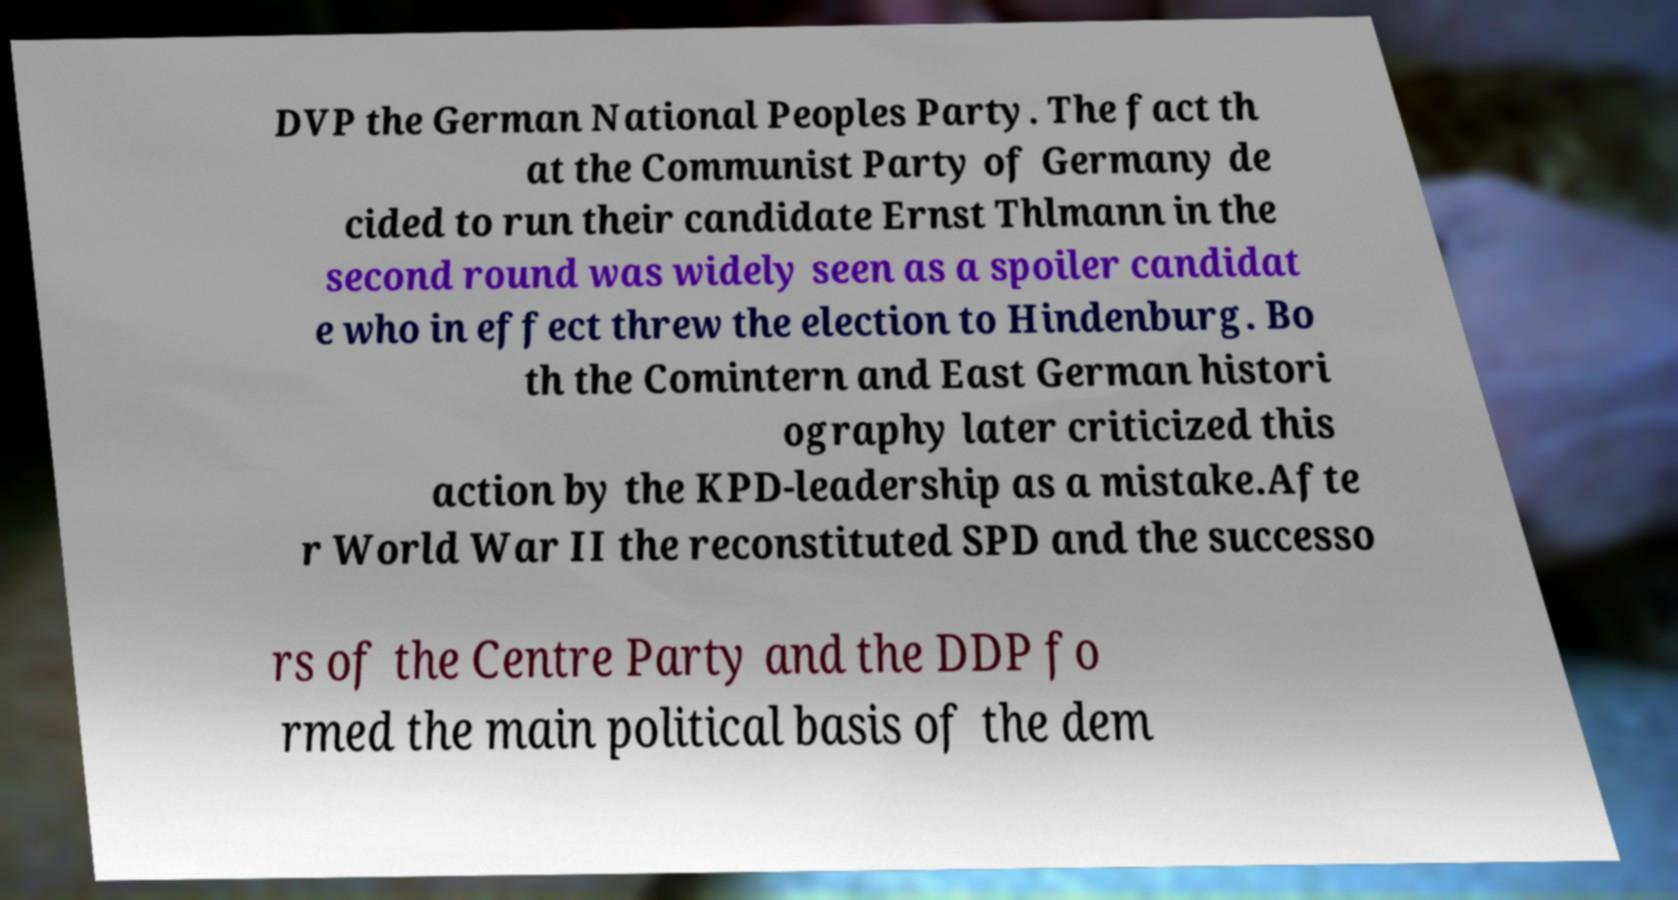Can you accurately transcribe the text from the provided image for me? DVP the German National Peoples Party. The fact th at the Communist Party of Germany de cided to run their candidate Ernst Thlmann in the second round was widely seen as a spoiler candidat e who in effect threw the election to Hindenburg. Bo th the Comintern and East German histori ography later criticized this action by the KPD-leadership as a mistake.Afte r World War II the reconstituted SPD and the successo rs of the Centre Party and the DDP fo rmed the main political basis of the dem 